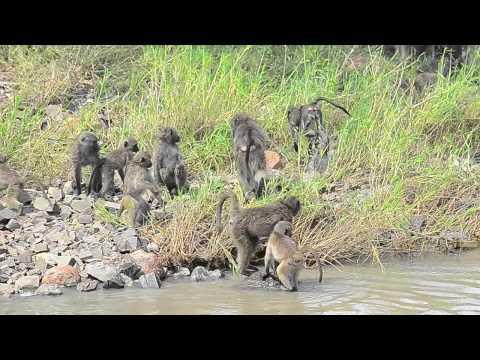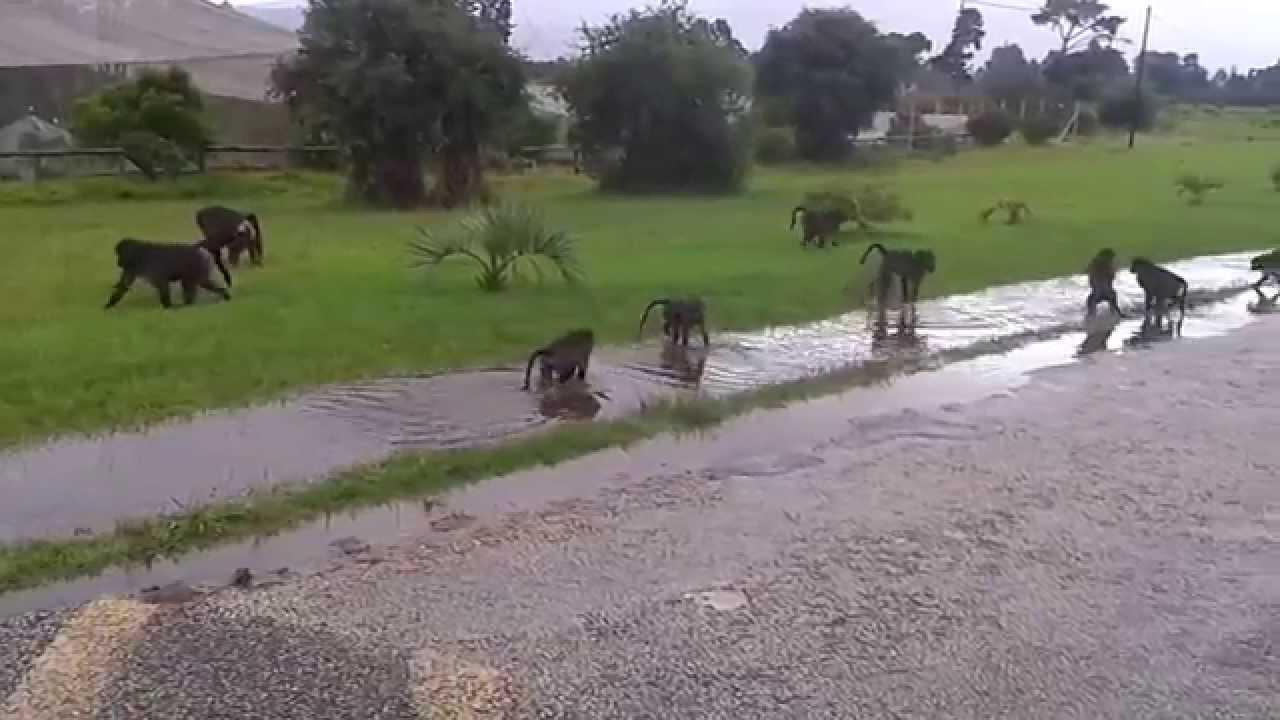The first image is the image on the left, the second image is the image on the right. Assess this claim about the two images: "An animal in the image on the right is sitting on a concrete railing.". Correct or not? Answer yes or no. No. The first image is the image on the left, the second image is the image on the right. For the images shown, is this caption "An image includes a baboon sitting on a manmade ledge of a pool." true? Answer yes or no. No. 